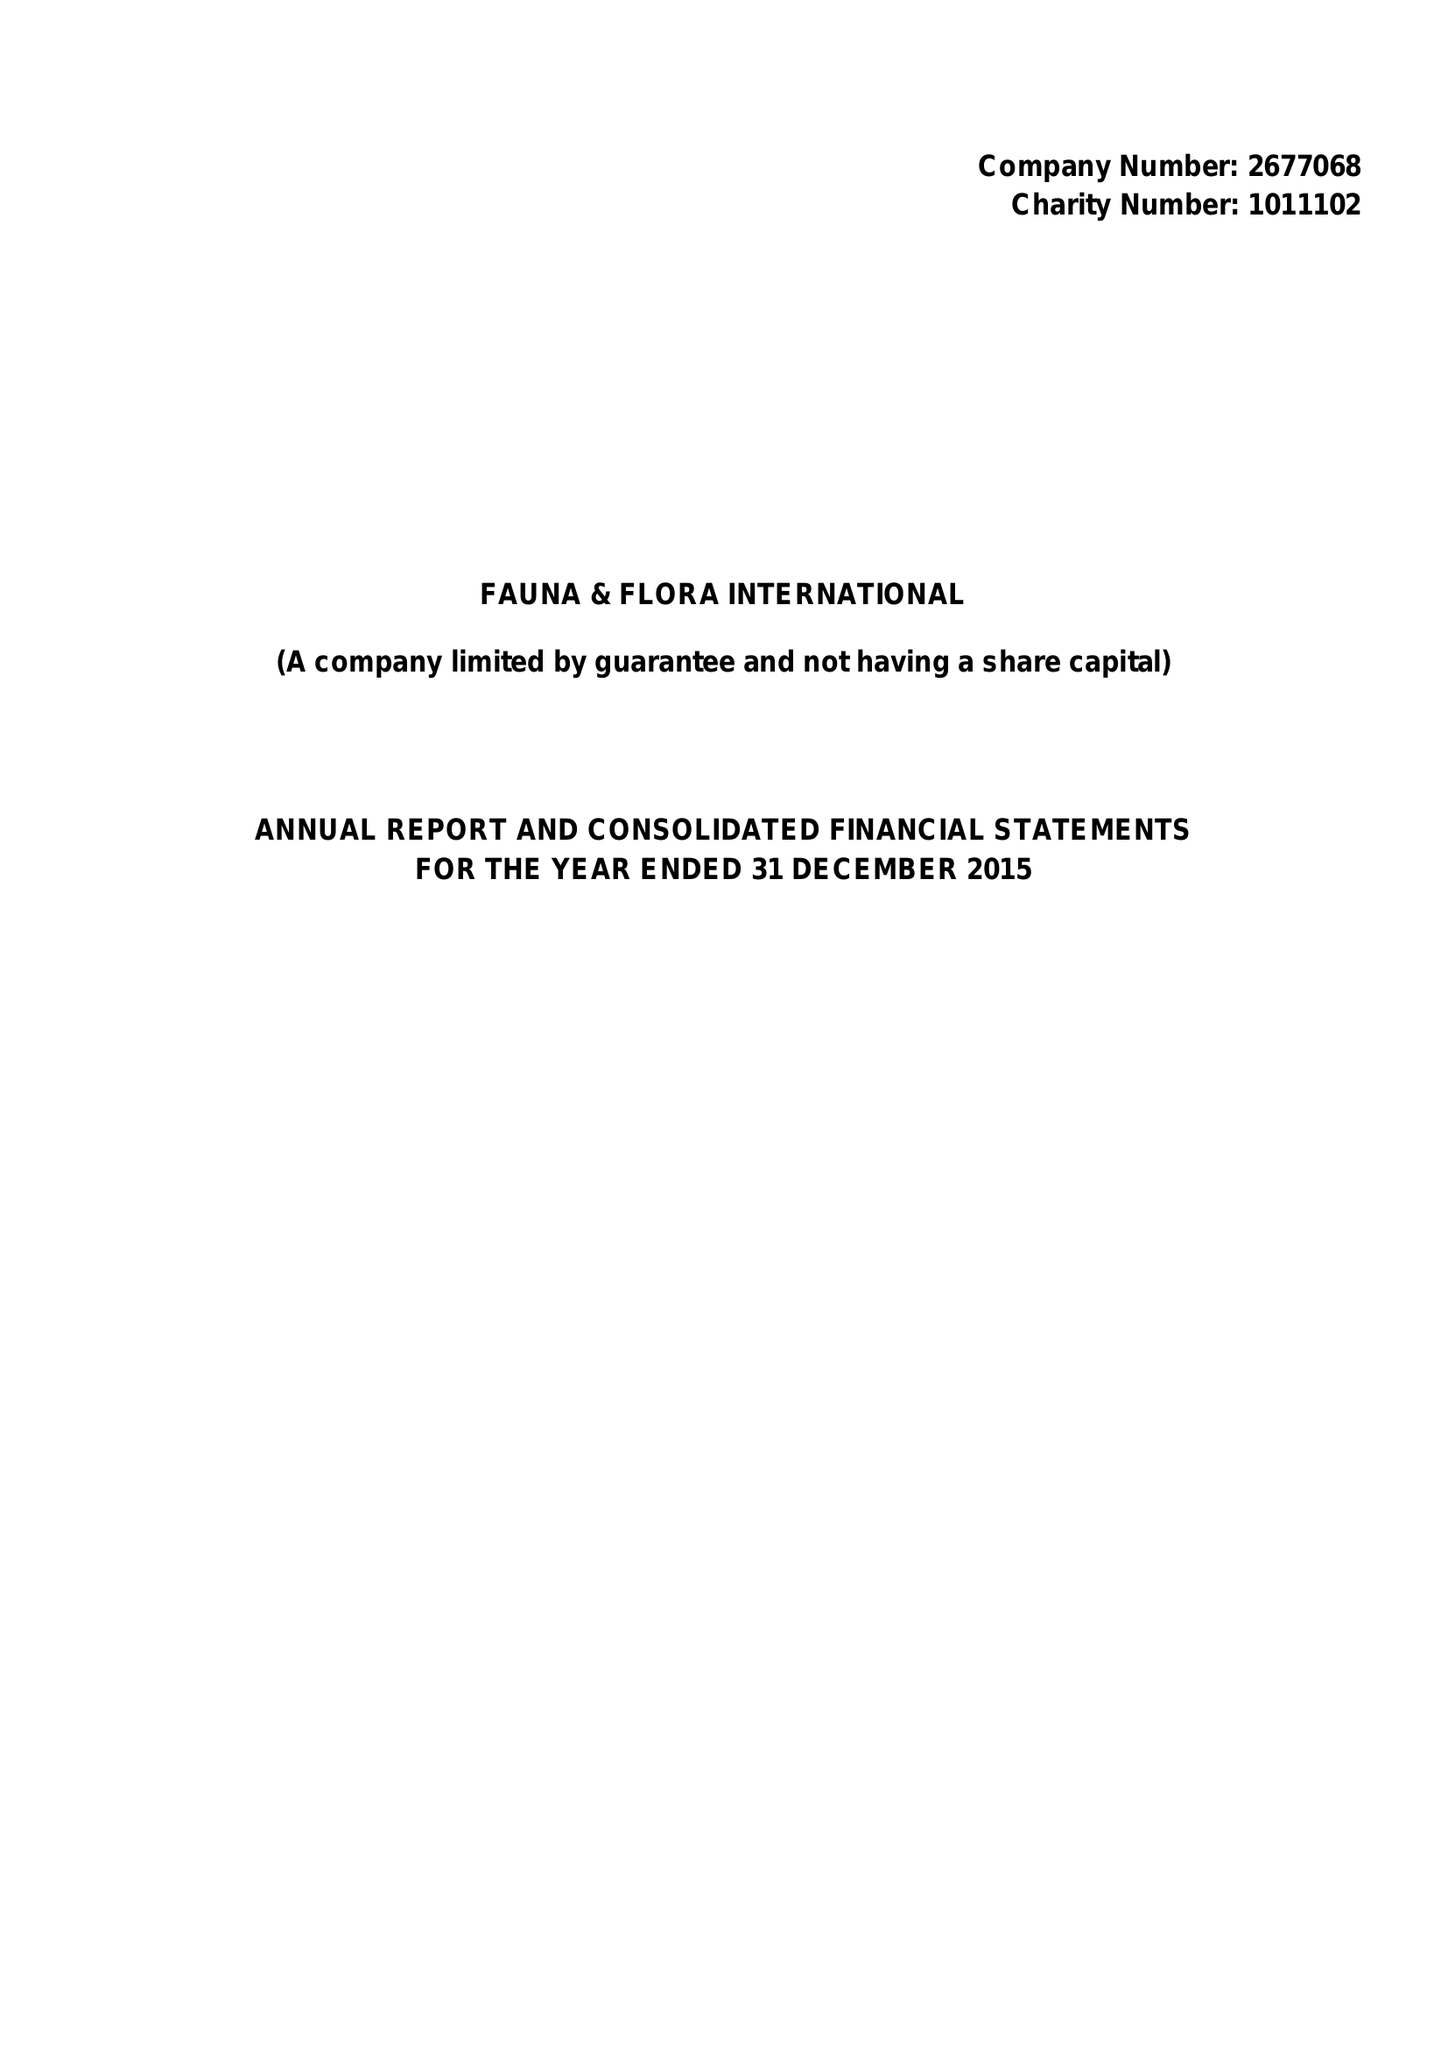What is the value for the spending_annually_in_british_pounds?
Answer the question using a single word or phrase. 16574345.00 